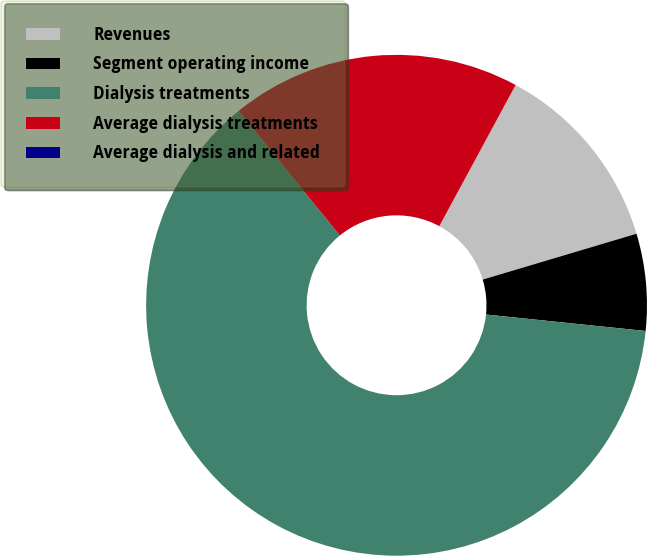Convert chart to OTSL. <chart><loc_0><loc_0><loc_500><loc_500><pie_chart><fcel>Revenues<fcel>Segment operating income<fcel>Dialysis treatments<fcel>Average dialysis treatments<fcel>Average dialysis and related<nl><fcel>12.5%<fcel>6.25%<fcel>62.5%<fcel>18.75%<fcel>0.0%<nl></chart> 